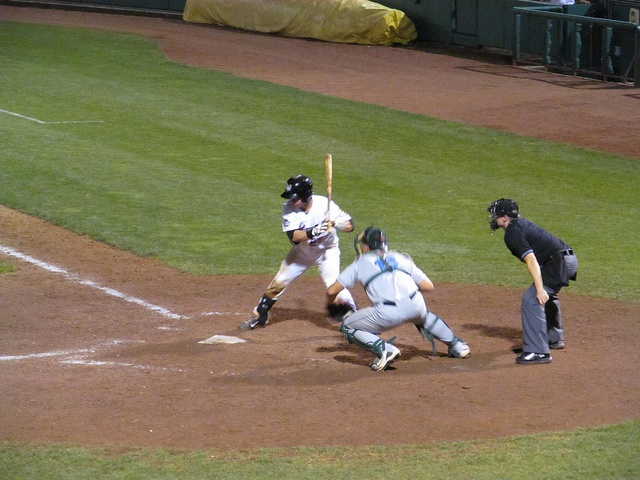Describe the objects in this image and their specific colors. I can see people in black, lavender, darkgray, and gray tones, people in black, white, gray, and darkgray tones, people in black and gray tones, baseball glove in black, gray, darkgray, and maroon tones, and baseball bat in black, tan, and ivory tones in this image. 